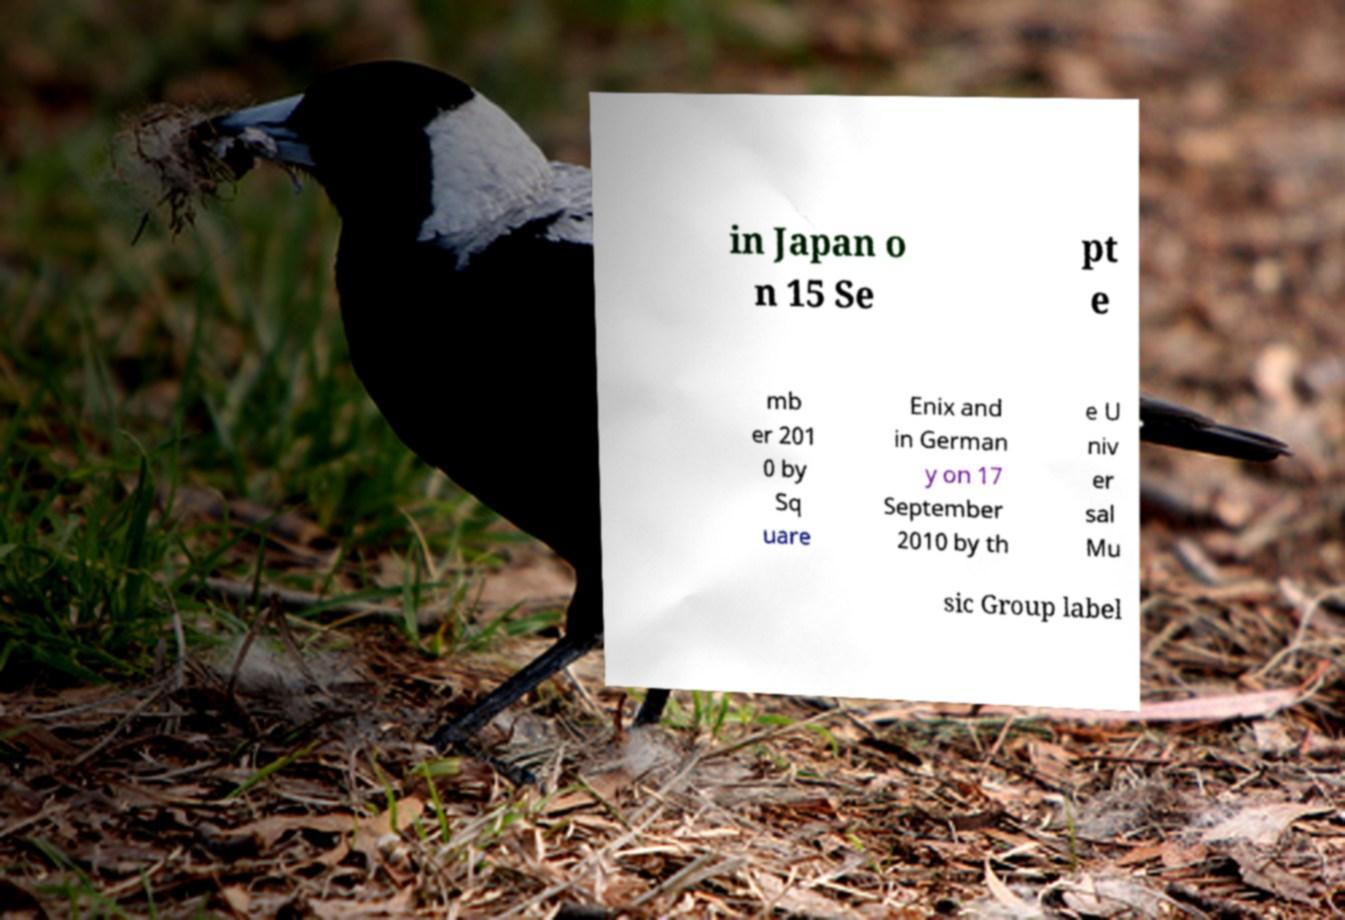Can you accurately transcribe the text from the provided image for me? in Japan o n 15 Se pt e mb er 201 0 by Sq uare Enix and in German y on 17 September 2010 by th e U niv er sal Mu sic Group label 